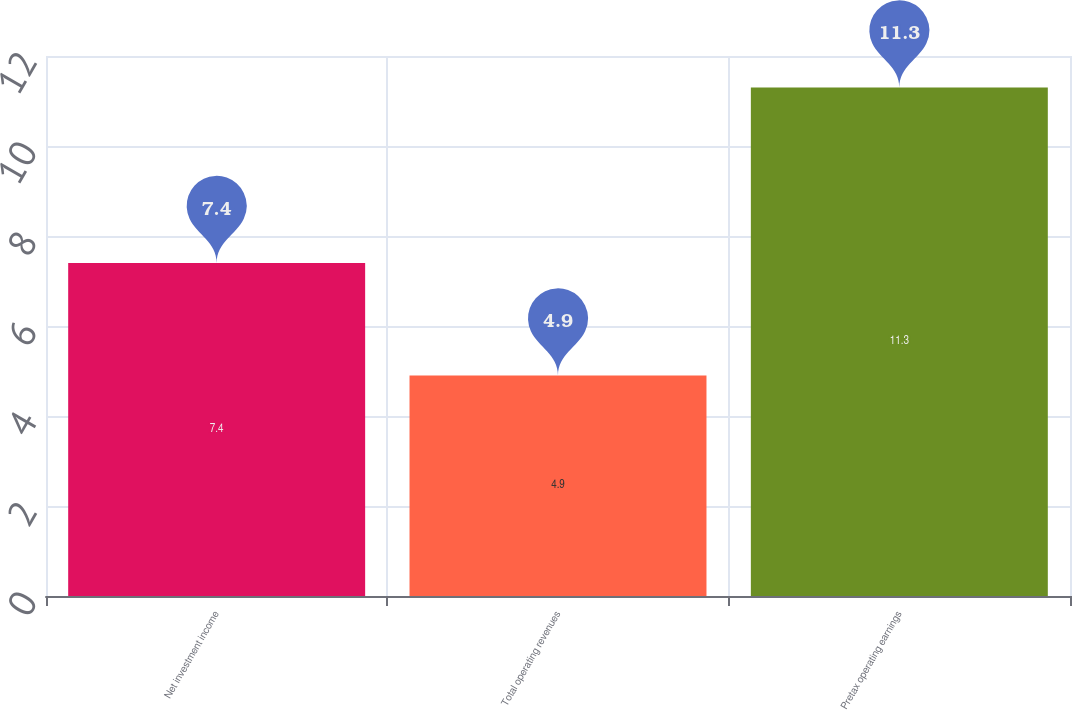Convert chart to OTSL. <chart><loc_0><loc_0><loc_500><loc_500><bar_chart><fcel>Net investment income<fcel>Total operating revenues<fcel>Pretax operating earnings<nl><fcel>7.4<fcel>4.9<fcel>11.3<nl></chart> 